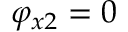<formula> <loc_0><loc_0><loc_500><loc_500>\varphi _ { x 2 } = 0</formula> 